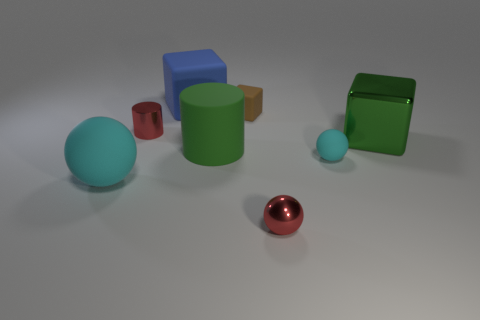How would you describe the lighting in this scene? The lighting in the scene is soft and diffused, creating gentle shadows and subtle highlights on the objects. This suggests an indoor setting with ambient lighting, simulating a natural, evenly distributed light source, possibly from overhead. 